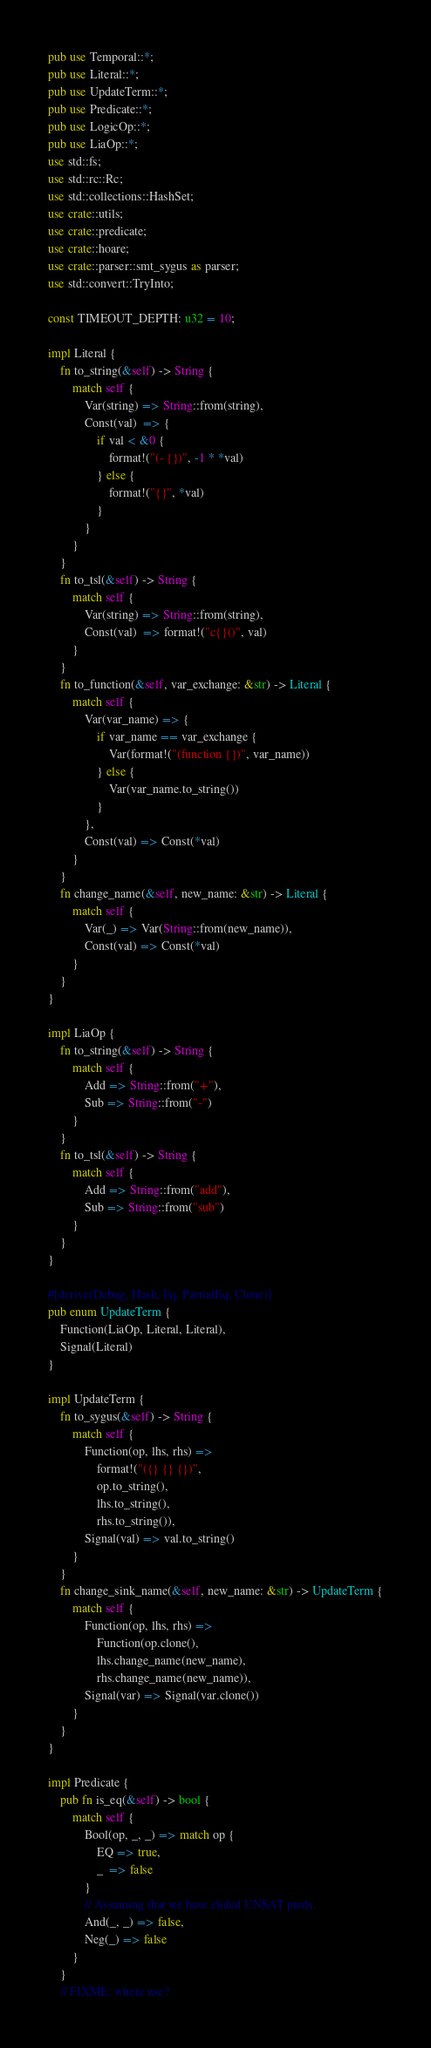Convert code to text. <code><loc_0><loc_0><loc_500><loc_500><_Rust_>pub use Temporal::*;
pub use Literal::*;
pub use UpdateTerm::*;
pub use Predicate::*;
pub use LogicOp::*;
pub use LiaOp::*;
use std::fs;
use std::rc::Rc;
use std::collections::HashSet;
use crate::utils;
use crate::predicate;
use crate::hoare;
use crate::parser::smt_sygus as parser;
use std::convert::TryInto;

const TIMEOUT_DEPTH: u32 = 10;

impl Literal {
    fn to_string(&self) -> String {
        match self {
            Var(string) => String::from(string),
            Const(val)  => {
                if val < &0 {
                    format!("(- {})", -1 * *val)
                } else {
                    format!("{}", *val)
                }
            } 
        }
    }
    fn to_tsl(&self) -> String {
        match self {
            Var(string) => String::from(string),
            Const(val)  => format!("c{}()", val)
        }
    }
    fn to_function(&self, var_exchange: &str) -> Literal {
        match self {
            Var(var_name) => {
                if var_name == var_exchange {
                    Var(format!("(function {})", var_name))
                } else {
                    Var(var_name.to_string())
                }
            },
            Const(val) => Const(*val)
        }
    }
    fn change_name(&self, new_name: &str) -> Literal {
        match self {
            Var(_) => Var(String::from(new_name)),
            Const(val) => Const(*val)
        }
    }
}

impl LiaOp {
    fn to_string(&self) -> String {
        match self {
            Add => String::from("+"),
            Sub => String::from("-")
        }
    }
    fn to_tsl(&self) -> String {
        match self {
            Add => String::from("add"),
            Sub => String::from("sub")
        }
    }
}

#[derive(Debug, Hash, Eq, PartialEq, Clone)]
pub enum UpdateTerm {
    Function(LiaOp, Literal, Literal),
    Signal(Literal)
}

impl UpdateTerm {
    fn to_sygus(&self) -> String {
        match self {
            Function(op, lhs, rhs) =>
                format!("({} {} {})",
                op.to_string(),
                lhs.to_string(),
                rhs.to_string()),
            Signal(val) => val.to_string()
        }
    }
    fn change_sink_name(&self, new_name: &str) -> UpdateTerm {
        match self {
            Function(op, lhs, rhs) =>
                Function(op.clone(),
                lhs.change_name(new_name),
                rhs.change_name(new_name)),
            Signal(var) => Signal(var.clone())
        }
    }
}

impl Predicate {
    pub fn is_eq(&self) -> bool {
        match self {
            Bool(op, _, _) => match op {
                EQ => true,
                _  => false
            }
            // Assuming that we have elided UNSAT preds.
            And(_, _) => false,
            Neg(_) => false
        }
    }
    // FIXME: where use?</code> 